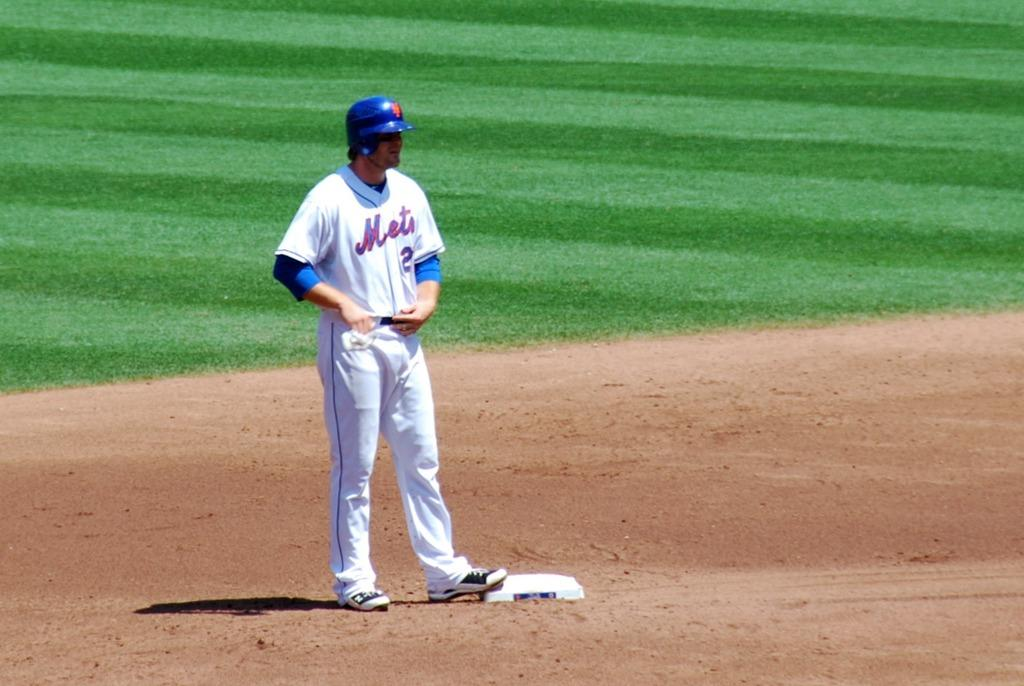<image>
Describe the image concisely. a player for the Mets is standing on a base, waiting to run 